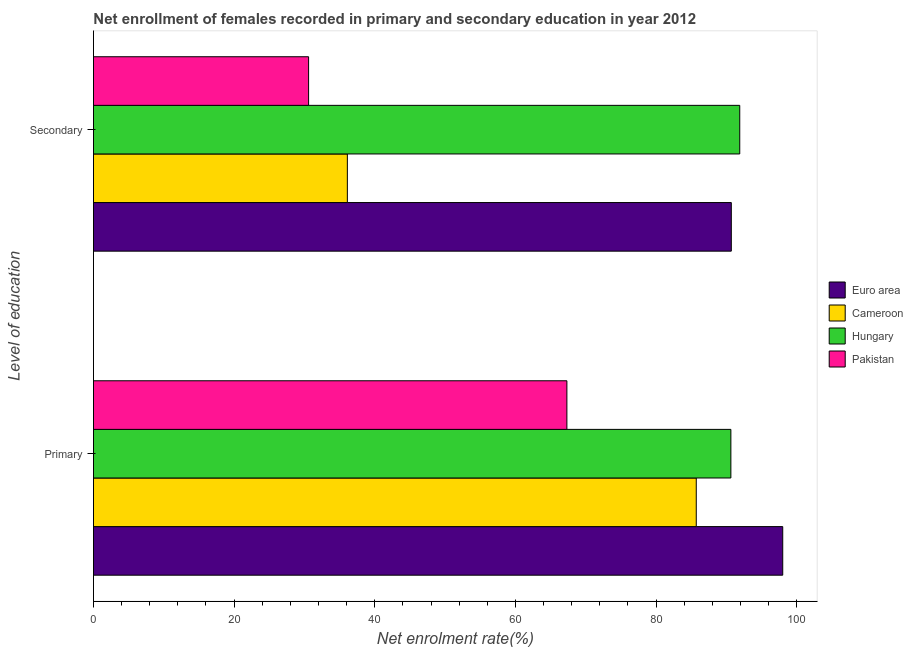How many groups of bars are there?
Give a very brief answer. 2. How many bars are there on the 1st tick from the top?
Your response must be concise. 4. What is the label of the 1st group of bars from the top?
Make the answer very short. Secondary. What is the enrollment rate in primary education in Euro area?
Offer a very short reply. 98.01. Across all countries, what is the maximum enrollment rate in primary education?
Give a very brief answer. 98.01. Across all countries, what is the minimum enrollment rate in primary education?
Keep it short and to the point. 67.32. In which country was the enrollment rate in secondary education maximum?
Your answer should be compact. Hungary. What is the total enrollment rate in primary education in the graph?
Offer a terse response. 341.69. What is the difference between the enrollment rate in primary education in Euro area and that in Pakistan?
Your answer should be very brief. 30.69. What is the difference between the enrollment rate in primary education in Pakistan and the enrollment rate in secondary education in Euro area?
Ensure brevity in your answer.  -23.38. What is the average enrollment rate in primary education per country?
Offer a terse response. 85.42. What is the difference between the enrollment rate in primary education and enrollment rate in secondary education in Cameroon?
Ensure brevity in your answer.  49.61. What is the ratio of the enrollment rate in primary education in Hungary to that in Euro area?
Offer a very short reply. 0.92. Is the enrollment rate in primary education in Euro area less than that in Cameroon?
Keep it short and to the point. No. In how many countries, is the enrollment rate in secondary education greater than the average enrollment rate in secondary education taken over all countries?
Provide a short and direct response. 2. What does the 2nd bar from the bottom in Primary represents?
Provide a short and direct response. Cameroon. How many countries are there in the graph?
Keep it short and to the point. 4. What is the difference between two consecutive major ticks on the X-axis?
Keep it short and to the point. 20. Does the graph contain any zero values?
Your answer should be compact. No. Does the graph contain grids?
Provide a short and direct response. No. Where does the legend appear in the graph?
Your answer should be very brief. Center right. How are the legend labels stacked?
Your answer should be compact. Vertical. What is the title of the graph?
Make the answer very short. Net enrollment of females recorded in primary and secondary education in year 2012. What is the label or title of the X-axis?
Keep it short and to the point. Net enrolment rate(%). What is the label or title of the Y-axis?
Your answer should be very brief. Level of education. What is the Net enrolment rate(%) of Euro area in Primary?
Your answer should be very brief. 98.01. What is the Net enrolment rate(%) in Cameroon in Primary?
Your answer should be compact. 85.72. What is the Net enrolment rate(%) in Hungary in Primary?
Offer a terse response. 90.64. What is the Net enrolment rate(%) of Pakistan in Primary?
Ensure brevity in your answer.  67.32. What is the Net enrolment rate(%) in Euro area in Secondary?
Your answer should be compact. 90.7. What is the Net enrolment rate(%) of Cameroon in Secondary?
Your answer should be very brief. 36.1. What is the Net enrolment rate(%) of Hungary in Secondary?
Your response must be concise. 91.9. What is the Net enrolment rate(%) of Pakistan in Secondary?
Your answer should be very brief. 30.59. Across all Level of education, what is the maximum Net enrolment rate(%) in Euro area?
Give a very brief answer. 98.01. Across all Level of education, what is the maximum Net enrolment rate(%) of Cameroon?
Make the answer very short. 85.72. Across all Level of education, what is the maximum Net enrolment rate(%) in Hungary?
Your response must be concise. 91.9. Across all Level of education, what is the maximum Net enrolment rate(%) of Pakistan?
Provide a short and direct response. 67.32. Across all Level of education, what is the minimum Net enrolment rate(%) in Euro area?
Your answer should be compact. 90.7. Across all Level of education, what is the minimum Net enrolment rate(%) in Cameroon?
Provide a short and direct response. 36.1. Across all Level of education, what is the minimum Net enrolment rate(%) in Hungary?
Keep it short and to the point. 90.64. Across all Level of education, what is the minimum Net enrolment rate(%) of Pakistan?
Provide a succinct answer. 30.59. What is the total Net enrolment rate(%) of Euro area in the graph?
Keep it short and to the point. 188.71. What is the total Net enrolment rate(%) in Cameroon in the graph?
Keep it short and to the point. 121.82. What is the total Net enrolment rate(%) in Hungary in the graph?
Your response must be concise. 182.54. What is the total Net enrolment rate(%) in Pakistan in the graph?
Your answer should be very brief. 97.91. What is the difference between the Net enrolment rate(%) in Euro area in Primary and that in Secondary?
Keep it short and to the point. 7.31. What is the difference between the Net enrolment rate(%) of Cameroon in Primary and that in Secondary?
Keep it short and to the point. 49.61. What is the difference between the Net enrolment rate(%) in Hungary in Primary and that in Secondary?
Keep it short and to the point. -1.26. What is the difference between the Net enrolment rate(%) in Pakistan in Primary and that in Secondary?
Make the answer very short. 36.73. What is the difference between the Net enrolment rate(%) of Euro area in Primary and the Net enrolment rate(%) of Cameroon in Secondary?
Provide a succinct answer. 61.91. What is the difference between the Net enrolment rate(%) in Euro area in Primary and the Net enrolment rate(%) in Hungary in Secondary?
Provide a short and direct response. 6.11. What is the difference between the Net enrolment rate(%) of Euro area in Primary and the Net enrolment rate(%) of Pakistan in Secondary?
Your answer should be compact. 67.42. What is the difference between the Net enrolment rate(%) in Cameroon in Primary and the Net enrolment rate(%) in Hungary in Secondary?
Make the answer very short. -6.18. What is the difference between the Net enrolment rate(%) of Cameroon in Primary and the Net enrolment rate(%) of Pakistan in Secondary?
Your answer should be very brief. 55.13. What is the difference between the Net enrolment rate(%) in Hungary in Primary and the Net enrolment rate(%) in Pakistan in Secondary?
Your answer should be very brief. 60.05. What is the average Net enrolment rate(%) in Euro area per Level of education?
Your answer should be compact. 94.36. What is the average Net enrolment rate(%) of Cameroon per Level of education?
Ensure brevity in your answer.  60.91. What is the average Net enrolment rate(%) of Hungary per Level of education?
Give a very brief answer. 91.27. What is the average Net enrolment rate(%) in Pakistan per Level of education?
Offer a very short reply. 48.96. What is the difference between the Net enrolment rate(%) in Euro area and Net enrolment rate(%) in Cameroon in Primary?
Offer a terse response. 12.3. What is the difference between the Net enrolment rate(%) of Euro area and Net enrolment rate(%) of Hungary in Primary?
Keep it short and to the point. 7.37. What is the difference between the Net enrolment rate(%) of Euro area and Net enrolment rate(%) of Pakistan in Primary?
Ensure brevity in your answer.  30.69. What is the difference between the Net enrolment rate(%) in Cameroon and Net enrolment rate(%) in Hungary in Primary?
Provide a short and direct response. -4.92. What is the difference between the Net enrolment rate(%) of Cameroon and Net enrolment rate(%) of Pakistan in Primary?
Your response must be concise. 18.4. What is the difference between the Net enrolment rate(%) of Hungary and Net enrolment rate(%) of Pakistan in Primary?
Ensure brevity in your answer.  23.32. What is the difference between the Net enrolment rate(%) in Euro area and Net enrolment rate(%) in Cameroon in Secondary?
Provide a short and direct response. 54.6. What is the difference between the Net enrolment rate(%) of Euro area and Net enrolment rate(%) of Hungary in Secondary?
Keep it short and to the point. -1.2. What is the difference between the Net enrolment rate(%) in Euro area and Net enrolment rate(%) in Pakistan in Secondary?
Offer a very short reply. 60.11. What is the difference between the Net enrolment rate(%) in Cameroon and Net enrolment rate(%) in Hungary in Secondary?
Offer a terse response. -55.8. What is the difference between the Net enrolment rate(%) of Cameroon and Net enrolment rate(%) of Pakistan in Secondary?
Ensure brevity in your answer.  5.51. What is the difference between the Net enrolment rate(%) of Hungary and Net enrolment rate(%) of Pakistan in Secondary?
Your answer should be very brief. 61.31. What is the ratio of the Net enrolment rate(%) of Euro area in Primary to that in Secondary?
Your response must be concise. 1.08. What is the ratio of the Net enrolment rate(%) of Cameroon in Primary to that in Secondary?
Make the answer very short. 2.37. What is the ratio of the Net enrolment rate(%) of Hungary in Primary to that in Secondary?
Offer a very short reply. 0.99. What is the ratio of the Net enrolment rate(%) of Pakistan in Primary to that in Secondary?
Keep it short and to the point. 2.2. What is the difference between the highest and the second highest Net enrolment rate(%) of Euro area?
Offer a very short reply. 7.31. What is the difference between the highest and the second highest Net enrolment rate(%) of Cameroon?
Make the answer very short. 49.61. What is the difference between the highest and the second highest Net enrolment rate(%) in Hungary?
Offer a terse response. 1.26. What is the difference between the highest and the second highest Net enrolment rate(%) of Pakistan?
Your answer should be compact. 36.73. What is the difference between the highest and the lowest Net enrolment rate(%) of Euro area?
Ensure brevity in your answer.  7.31. What is the difference between the highest and the lowest Net enrolment rate(%) in Cameroon?
Offer a terse response. 49.61. What is the difference between the highest and the lowest Net enrolment rate(%) of Hungary?
Make the answer very short. 1.26. What is the difference between the highest and the lowest Net enrolment rate(%) of Pakistan?
Ensure brevity in your answer.  36.73. 